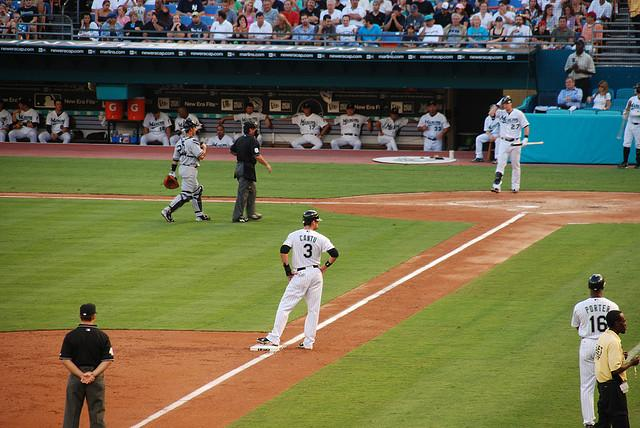What's the area where players are seated on a bench near gatorade coolers?

Choices:
A) dugout
B) locker room
C) home court
D) home base dugout 